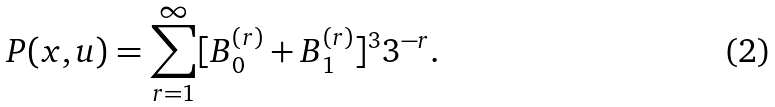<formula> <loc_0><loc_0><loc_500><loc_500>P ( x , u ) = \sum _ { r = 1 } ^ { \infty } [ B _ { 0 } ^ { ( r ) } + B _ { 1 } ^ { ( r ) } ] ^ { 3 } 3 ^ { - r } .</formula> 